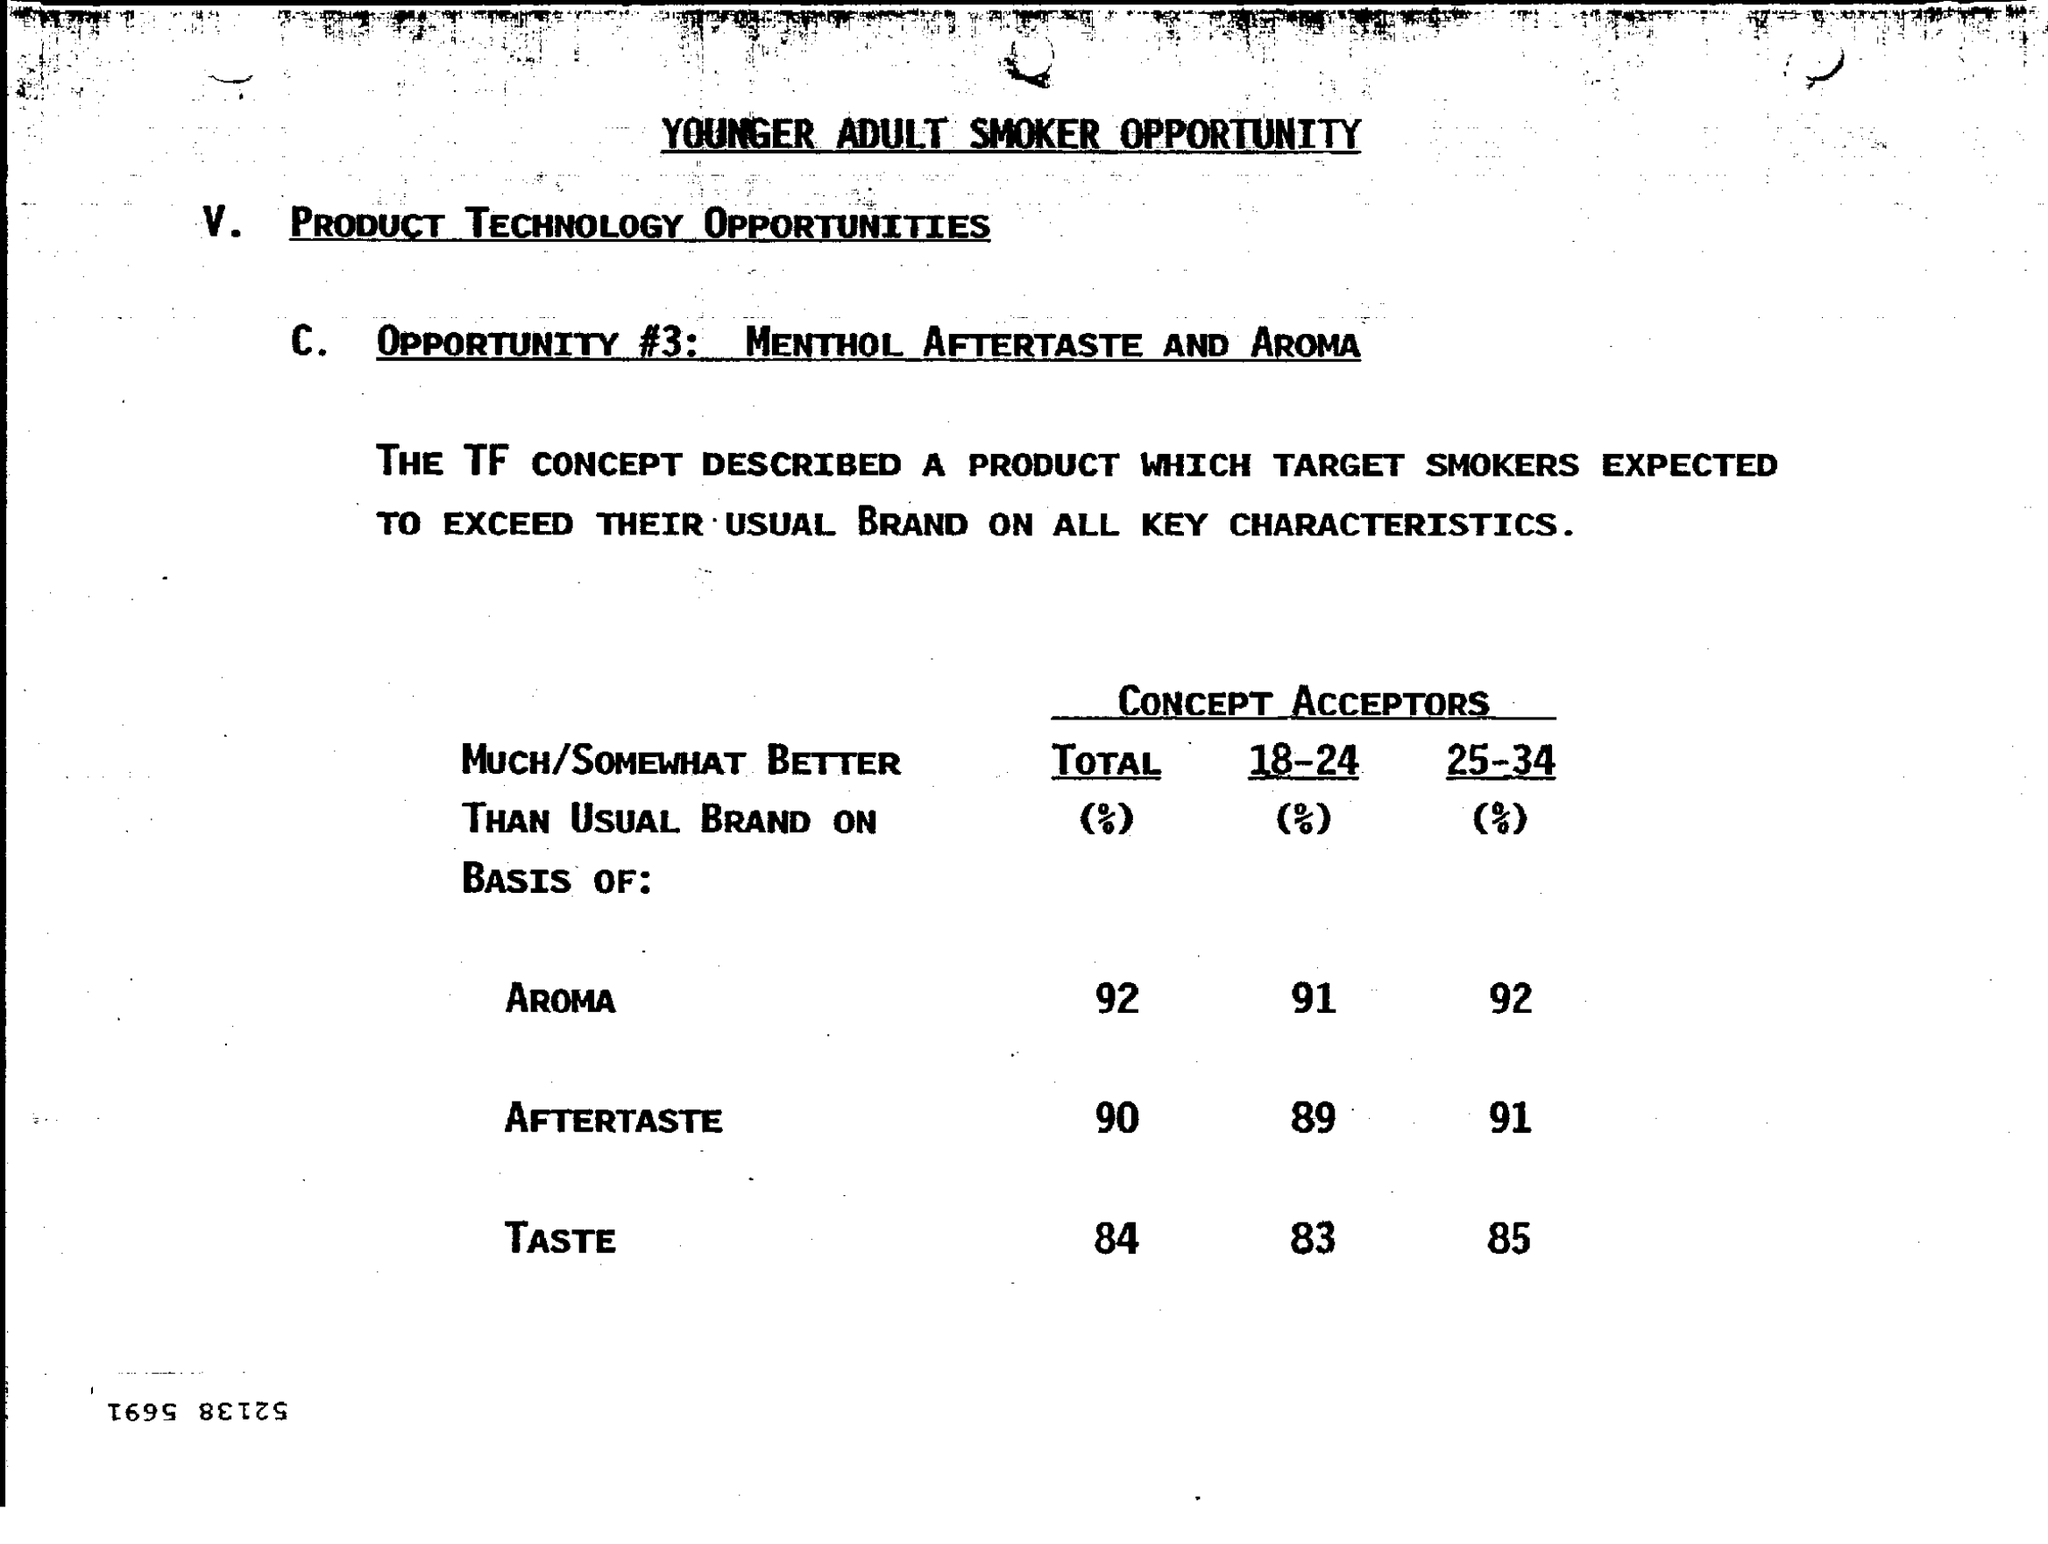Specify some key components in this picture. In total, aroma makes up approximately 92% of the composition of the sample. The aroma for 25-34% alcohol content is present at 92%. The total taste percentage is 84%. After tasting the food, a significant percentage of the panelists reported experiencing after taste, with 90% of the panelists indicating that they tasted after taste. The aroma for a liquid with an alcohol content of 18-24% is 91%. 